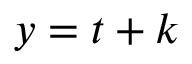<formula> <loc_0><loc_0><loc_500><loc_500>y = t + k</formula> 